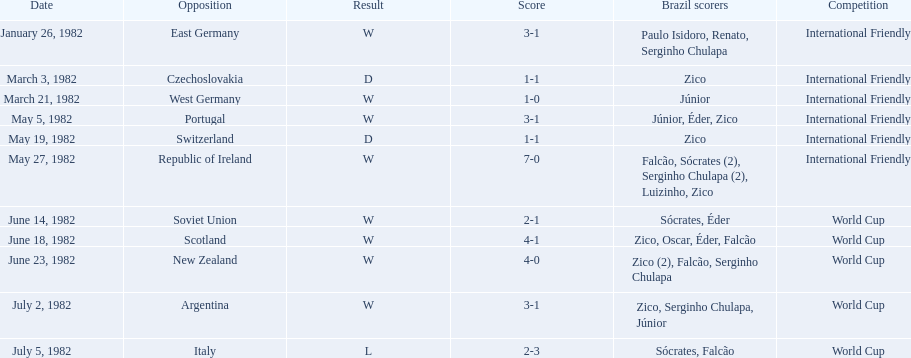What were the results of each match in the 1982 brazilian soccer matches? 3-1, 1-1, 1-0, 3-1, 1-1, 7-0, 2-1, 4-1, 4-0, 3-1, 2-3. Of these, which were the outcomes from matches against portugal and the soviet union? 3-1, 2-1. And between those two matches, against which nation did brazil score more goals? Portugal. Can you give me this table as a dict? {'header': ['Date', 'Opposition', 'Result', 'Score', 'Brazil scorers', 'Competition'], 'rows': [['January 26, 1982', 'East Germany', 'W', '3-1', 'Paulo Isidoro, Renato, Serginho Chulapa', 'International Friendly'], ['March 3, 1982', 'Czechoslovakia', 'D', '1-1', 'Zico', 'International Friendly'], ['March 21, 1982', 'West Germany', 'W', '1-0', 'Júnior', 'International Friendly'], ['May 5, 1982', 'Portugal', 'W', '3-1', 'Júnior, Éder, Zico', 'International Friendly'], ['May 19, 1982', 'Switzerland', 'D', '1-1', 'Zico', 'International Friendly'], ['May 27, 1982', 'Republic of Ireland', 'W', '7-0', 'Falcão, Sócrates (2), Serginho Chulapa (2), Luizinho, Zico', 'International Friendly'], ['June 14, 1982', 'Soviet Union', 'W', '2-1', 'Sócrates, Éder', 'World Cup'], ['June 18, 1982', 'Scotland', 'W', '4-1', 'Zico, Oscar, Éder, Falcão', 'World Cup'], ['June 23, 1982', 'New Zealand', 'W', '4-0', 'Zico (2), Falcão, Serginho Chulapa', 'World Cup'], ['July 2, 1982', 'Argentina', 'W', '3-1', 'Zico, Serginho Chulapa, Júnior', 'World Cup'], ['July 5, 1982', 'Italy', 'L', '2-3', 'Sócrates, Falcão', 'World Cup']]} 